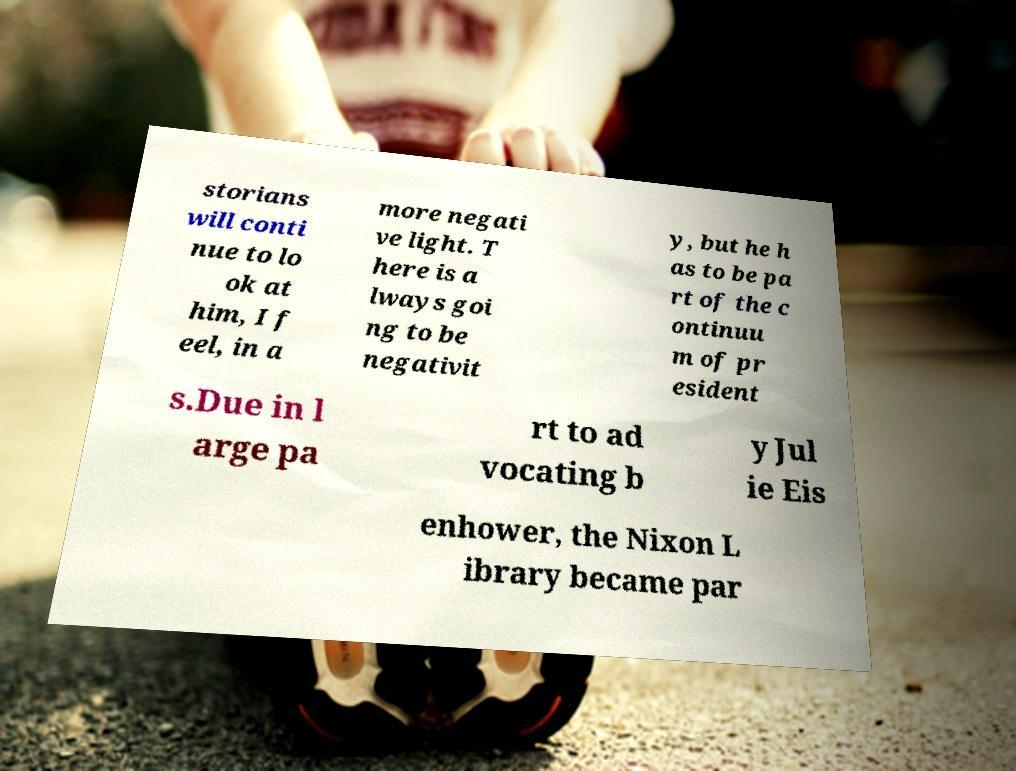What messages or text are displayed in this image? I need them in a readable, typed format. storians will conti nue to lo ok at him, I f eel, in a more negati ve light. T here is a lways goi ng to be negativit y, but he h as to be pa rt of the c ontinuu m of pr esident s.Due in l arge pa rt to ad vocating b y Jul ie Eis enhower, the Nixon L ibrary became par 